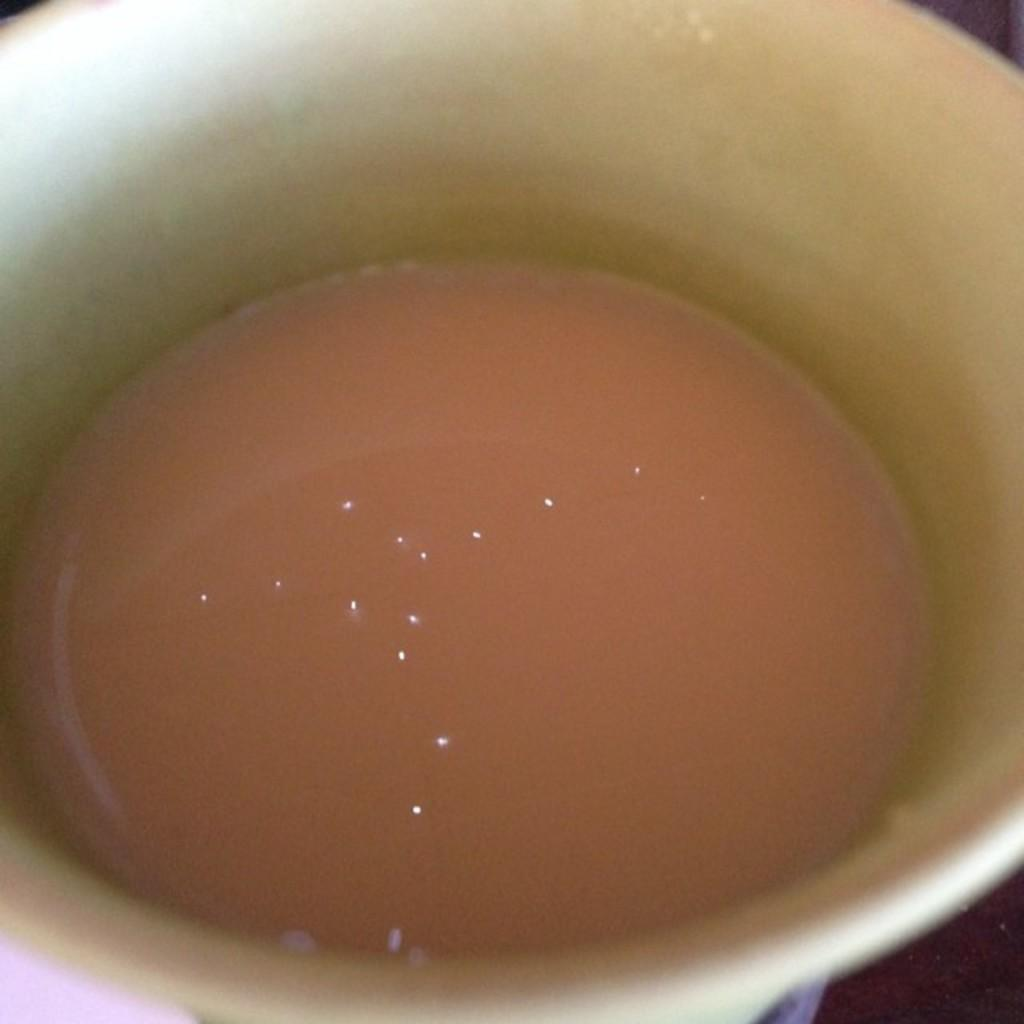What is present in the image? There is a cup in the image. What is the opinion of the snails about the teaching methods in the image? There are no snails or teaching methods present in the image, so it is not possible to determine their opinions. 